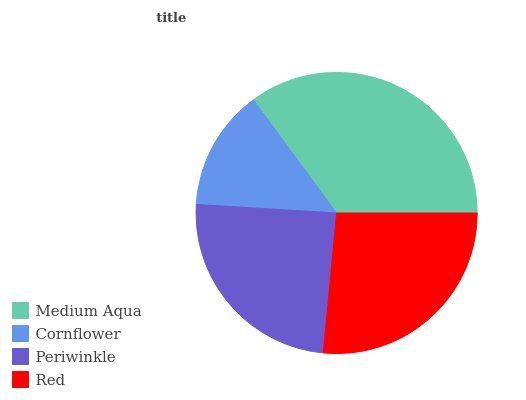Is Cornflower the minimum?
Answer yes or no. Yes. Is Medium Aqua the maximum?
Answer yes or no. Yes. Is Periwinkle the minimum?
Answer yes or no. No. Is Periwinkle the maximum?
Answer yes or no. No. Is Periwinkle greater than Cornflower?
Answer yes or no. Yes. Is Cornflower less than Periwinkle?
Answer yes or no. Yes. Is Cornflower greater than Periwinkle?
Answer yes or no. No. Is Periwinkle less than Cornflower?
Answer yes or no. No. Is Red the high median?
Answer yes or no. Yes. Is Periwinkle the low median?
Answer yes or no. Yes. Is Medium Aqua the high median?
Answer yes or no. No. Is Cornflower the low median?
Answer yes or no. No. 